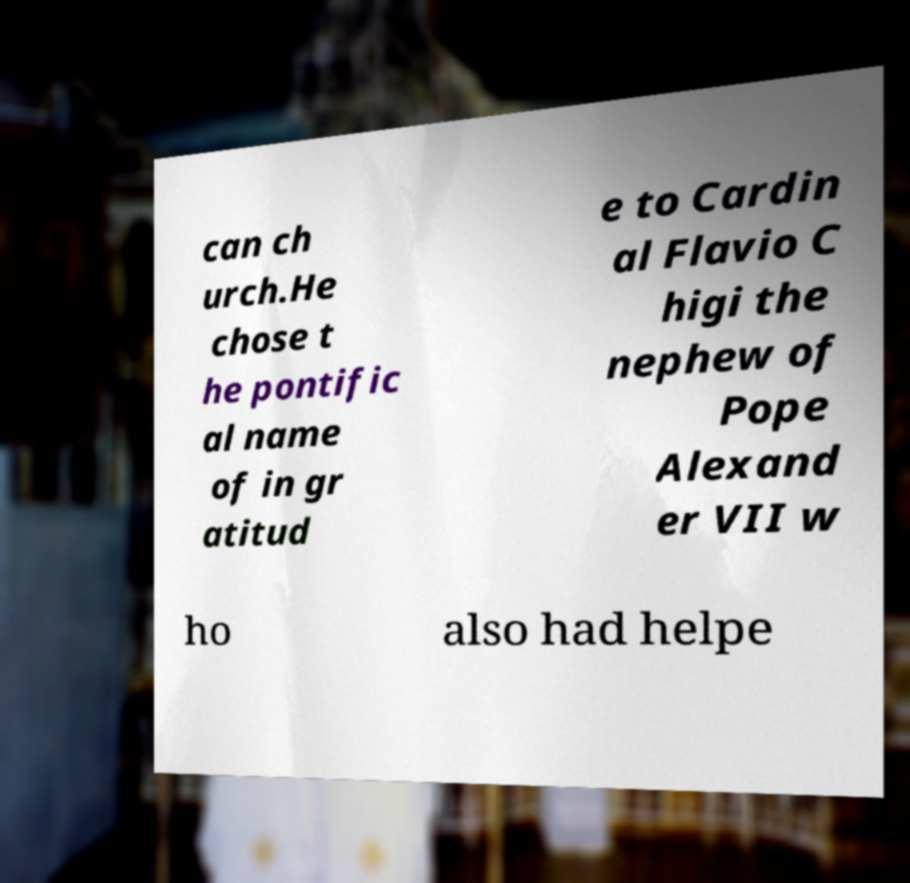There's text embedded in this image that I need extracted. Can you transcribe it verbatim? can ch urch.He chose t he pontific al name of in gr atitud e to Cardin al Flavio C higi the nephew of Pope Alexand er VII w ho also had helpe 